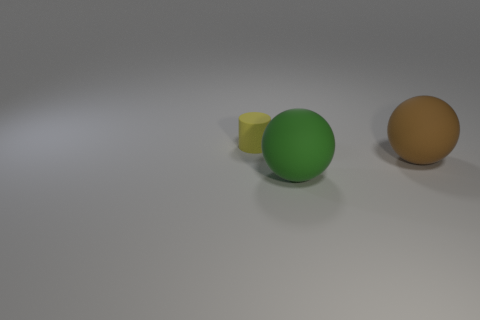Are there more small yellow matte objects behind the green object than objects that are in front of the yellow rubber cylinder?
Your answer should be compact. No. How many balls have the same material as the green object?
Offer a terse response. 1. Is the green matte thing the same size as the brown thing?
Provide a succinct answer. Yes. The tiny matte cylinder is what color?
Offer a very short reply. Yellow. How many things are either blue rubber things or small rubber cylinders?
Provide a succinct answer. 1. Is there another big matte object of the same shape as the green rubber object?
Provide a succinct answer. Yes. What shape is the small yellow rubber object behind the object on the right side of the green object?
Your response must be concise. Cylinder. Are there any rubber balls that have the same size as the yellow matte object?
Offer a very short reply. No. Are there fewer small brown matte cubes than rubber balls?
Your answer should be very brief. Yes. What shape is the large thing to the left of the large matte ball that is behind the sphere on the left side of the brown rubber thing?
Give a very brief answer. Sphere. 